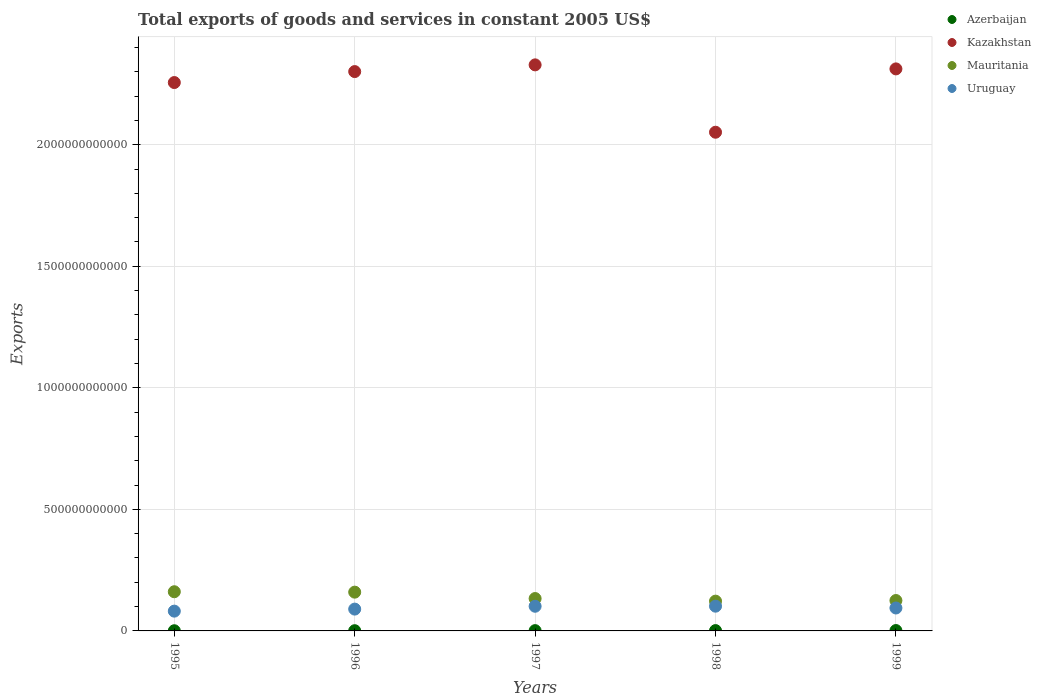What is the total exports of goods and services in Mauritania in 1995?
Ensure brevity in your answer.  1.61e+11. Across all years, what is the maximum total exports of goods and services in Uruguay?
Your answer should be compact. 1.02e+11. Across all years, what is the minimum total exports of goods and services in Azerbaijan?
Your response must be concise. 7.61e+08. In which year was the total exports of goods and services in Azerbaijan maximum?
Give a very brief answer. 1999. What is the total total exports of goods and services in Uruguay in the graph?
Ensure brevity in your answer.  4.69e+11. What is the difference between the total exports of goods and services in Mauritania in 1997 and that in 1998?
Offer a very short reply. 1.08e+1. What is the difference between the total exports of goods and services in Uruguay in 1998 and the total exports of goods and services in Azerbaijan in 1996?
Give a very brief answer. 1.01e+11. What is the average total exports of goods and services in Uruguay per year?
Your answer should be compact. 9.37e+1. In the year 1997, what is the difference between the total exports of goods and services in Azerbaijan and total exports of goods and services in Uruguay?
Provide a short and direct response. -1.00e+11. What is the ratio of the total exports of goods and services in Azerbaijan in 1996 to that in 1998?
Offer a very short reply. 0.67. Is the total exports of goods and services in Azerbaijan in 1996 less than that in 1997?
Offer a terse response. Yes. Is the difference between the total exports of goods and services in Azerbaijan in 1995 and 1998 greater than the difference between the total exports of goods and services in Uruguay in 1995 and 1998?
Provide a succinct answer. Yes. What is the difference between the highest and the second highest total exports of goods and services in Azerbaijan?
Keep it short and to the point. 1.83e+08. What is the difference between the highest and the lowest total exports of goods and services in Azerbaijan?
Keep it short and to the point. 7.80e+08. In how many years, is the total exports of goods and services in Kazakhstan greater than the average total exports of goods and services in Kazakhstan taken over all years?
Offer a very short reply. 4. Is the sum of the total exports of goods and services in Uruguay in 1996 and 1997 greater than the maximum total exports of goods and services in Mauritania across all years?
Your response must be concise. Yes. Is it the case that in every year, the sum of the total exports of goods and services in Mauritania and total exports of goods and services in Kazakhstan  is greater than the sum of total exports of goods and services in Uruguay and total exports of goods and services in Azerbaijan?
Offer a very short reply. Yes. Does the total exports of goods and services in Azerbaijan monotonically increase over the years?
Your response must be concise. Yes. Is the total exports of goods and services in Kazakhstan strictly less than the total exports of goods and services in Mauritania over the years?
Keep it short and to the point. No. How many dotlines are there?
Keep it short and to the point. 4. What is the difference between two consecutive major ticks on the Y-axis?
Provide a succinct answer. 5.00e+11. Are the values on the major ticks of Y-axis written in scientific E-notation?
Provide a short and direct response. No. Does the graph contain any zero values?
Your answer should be compact. No. Where does the legend appear in the graph?
Offer a terse response. Top right. How many legend labels are there?
Your answer should be compact. 4. How are the legend labels stacked?
Ensure brevity in your answer.  Vertical. What is the title of the graph?
Give a very brief answer. Total exports of goods and services in constant 2005 US$. What is the label or title of the X-axis?
Offer a very short reply. Years. What is the label or title of the Y-axis?
Give a very brief answer. Exports. What is the Exports in Azerbaijan in 1995?
Your response must be concise. 7.61e+08. What is the Exports of Kazakhstan in 1995?
Provide a succinct answer. 2.26e+12. What is the Exports in Mauritania in 1995?
Your answer should be compact. 1.61e+11. What is the Exports of Uruguay in 1995?
Offer a terse response. 8.14e+1. What is the Exports of Azerbaijan in 1996?
Offer a terse response. 9.16e+08. What is the Exports in Kazakhstan in 1996?
Your answer should be compact. 2.30e+12. What is the Exports of Mauritania in 1996?
Give a very brief answer. 1.60e+11. What is the Exports in Uruguay in 1996?
Give a very brief answer. 8.98e+1. What is the Exports in Azerbaijan in 1997?
Provide a short and direct response. 1.18e+09. What is the Exports in Kazakhstan in 1997?
Your response must be concise. 2.33e+12. What is the Exports of Mauritania in 1997?
Offer a terse response. 1.33e+11. What is the Exports in Uruguay in 1997?
Provide a succinct answer. 1.01e+11. What is the Exports in Azerbaijan in 1998?
Make the answer very short. 1.36e+09. What is the Exports in Kazakhstan in 1998?
Offer a terse response. 2.05e+12. What is the Exports of Mauritania in 1998?
Give a very brief answer. 1.22e+11. What is the Exports of Uruguay in 1998?
Offer a terse response. 1.02e+11. What is the Exports in Azerbaijan in 1999?
Keep it short and to the point. 1.54e+09. What is the Exports of Kazakhstan in 1999?
Keep it short and to the point. 2.31e+12. What is the Exports of Mauritania in 1999?
Make the answer very short. 1.25e+11. What is the Exports in Uruguay in 1999?
Keep it short and to the point. 9.43e+1. Across all years, what is the maximum Exports of Azerbaijan?
Provide a succinct answer. 1.54e+09. Across all years, what is the maximum Exports of Kazakhstan?
Your response must be concise. 2.33e+12. Across all years, what is the maximum Exports of Mauritania?
Your answer should be very brief. 1.61e+11. Across all years, what is the maximum Exports in Uruguay?
Your answer should be very brief. 1.02e+11. Across all years, what is the minimum Exports of Azerbaijan?
Keep it short and to the point. 7.61e+08. Across all years, what is the minimum Exports in Kazakhstan?
Your response must be concise. 2.05e+12. Across all years, what is the minimum Exports of Mauritania?
Your answer should be compact. 1.22e+11. Across all years, what is the minimum Exports in Uruguay?
Keep it short and to the point. 8.14e+1. What is the total Exports in Azerbaijan in the graph?
Offer a terse response. 5.76e+09. What is the total Exports in Kazakhstan in the graph?
Make the answer very short. 1.12e+13. What is the total Exports in Mauritania in the graph?
Offer a very short reply. 7.01e+11. What is the total Exports in Uruguay in the graph?
Your answer should be very brief. 4.69e+11. What is the difference between the Exports of Azerbaijan in 1995 and that in 1996?
Offer a terse response. -1.55e+08. What is the difference between the Exports in Kazakhstan in 1995 and that in 1996?
Give a very brief answer. -4.51e+1. What is the difference between the Exports in Mauritania in 1995 and that in 1996?
Give a very brief answer. 1.68e+09. What is the difference between the Exports of Uruguay in 1995 and that in 1996?
Give a very brief answer. -8.37e+09. What is the difference between the Exports in Azerbaijan in 1995 and that in 1997?
Provide a succinct answer. -4.22e+08. What is the difference between the Exports in Kazakhstan in 1995 and that in 1997?
Offer a terse response. -7.27e+1. What is the difference between the Exports of Mauritania in 1995 and that in 1997?
Your answer should be very brief. 2.80e+1. What is the difference between the Exports of Uruguay in 1995 and that in 1997?
Offer a very short reply. -2.01e+1. What is the difference between the Exports in Azerbaijan in 1995 and that in 1998?
Make the answer very short. -5.97e+08. What is the difference between the Exports of Kazakhstan in 1995 and that in 1998?
Offer a terse response. 2.04e+11. What is the difference between the Exports of Mauritania in 1995 and that in 1998?
Make the answer very short. 3.87e+1. What is the difference between the Exports in Uruguay in 1995 and that in 1998?
Ensure brevity in your answer.  -2.04e+1. What is the difference between the Exports of Azerbaijan in 1995 and that in 1999?
Give a very brief answer. -7.80e+08. What is the difference between the Exports in Kazakhstan in 1995 and that in 1999?
Provide a short and direct response. -5.62e+1. What is the difference between the Exports in Mauritania in 1995 and that in 1999?
Provide a short and direct response. 3.61e+1. What is the difference between the Exports in Uruguay in 1995 and that in 1999?
Offer a terse response. -1.29e+1. What is the difference between the Exports in Azerbaijan in 1996 and that in 1997?
Give a very brief answer. -2.67e+08. What is the difference between the Exports of Kazakhstan in 1996 and that in 1997?
Provide a short and direct response. -2.76e+1. What is the difference between the Exports of Mauritania in 1996 and that in 1997?
Offer a very short reply. 2.63e+1. What is the difference between the Exports in Uruguay in 1996 and that in 1997?
Keep it short and to the point. -1.17e+1. What is the difference between the Exports in Azerbaijan in 1996 and that in 1998?
Offer a very short reply. -4.43e+08. What is the difference between the Exports in Kazakhstan in 1996 and that in 1998?
Give a very brief answer. 2.49e+11. What is the difference between the Exports in Mauritania in 1996 and that in 1998?
Provide a succinct answer. 3.70e+1. What is the difference between the Exports of Uruguay in 1996 and that in 1998?
Offer a terse response. -1.20e+1. What is the difference between the Exports in Azerbaijan in 1996 and that in 1999?
Offer a very short reply. -6.25e+08. What is the difference between the Exports in Kazakhstan in 1996 and that in 1999?
Your answer should be compact. -1.10e+1. What is the difference between the Exports of Mauritania in 1996 and that in 1999?
Provide a succinct answer. 3.45e+1. What is the difference between the Exports of Uruguay in 1996 and that in 1999?
Offer a very short reply. -4.53e+09. What is the difference between the Exports of Azerbaijan in 1997 and that in 1998?
Provide a succinct answer. -1.75e+08. What is the difference between the Exports in Kazakhstan in 1997 and that in 1998?
Your answer should be compact. 2.77e+11. What is the difference between the Exports of Mauritania in 1997 and that in 1998?
Offer a very short reply. 1.08e+1. What is the difference between the Exports in Uruguay in 1997 and that in 1998?
Your response must be concise. -3.39e+08. What is the difference between the Exports of Azerbaijan in 1997 and that in 1999?
Provide a succinct answer. -3.58e+08. What is the difference between the Exports in Kazakhstan in 1997 and that in 1999?
Offer a very short reply. 1.66e+1. What is the difference between the Exports of Mauritania in 1997 and that in 1999?
Offer a terse response. 8.16e+09. What is the difference between the Exports of Uruguay in 1997 and that in 1999?
Your answer should be very brief. 7.16e+09. What is the difference between the Exports in Azerbaijan in 1998 and that in 1999?
Offer a terse response. -1.83e+08. What is the difference between the Exports of Kazakhstan in 1998 and that in 1999?
Make the answer very short. -2.61e+11. What is the difference between the Exports in Mauritania in 1998 and that in 1999?
Provide a short and direct response. -2.59e+09. What is the difference between the Exports in Uruguay in 1998 and that in 1999?
Provide a short and direct response. 7.50e+09. What is the difference between the Exports of Azerbaijan in 1995 and the Exports of Kazakhstan in 1996?
Ensure brevity in your answer.  -2.30e+12. What is the difference between the Exports in Azerbaijan in 1995 and the Exports in Mauritania in 1996?
Provide a short and direct response. -1.59e+11. What is the difference between the Exports in Azerbaijan in 1995 and the Exports in Uruguay in 1996?
Your response must be concise. -8.90e+1. What is the difference between the Exports of Kazakhstan in 1995 and the Exports of Mauritania in 1996?
Give a very brief answer. 2.10e+12. What is the difference between the Exports of Kazakhstan in 1995 and the Exports of Uruguay in 1996?
Keep it short and to the point. 2.17e+12. What is the difference between the Exports of Mauritania in 1995 and the Exports of Uruguay in 1996?
Your answer should be very brief. 7.14e+1. What is the difference between the Exports in Azerbaijan in 1995 and the Exports in Kazakhstan in 1997?
Give a very brief answer. -2.33e+12. What is the difference between the Exports in Azerbaijan in 1995 and the Exports in Mauritania in 1997?
Offer a terse response. -1.32e+11. What is the difference between the Exports of Azerbaijan in 1995 and the Exports of Uruguay in 1997?
Provide a short and direct response. -1.01e+11. What is the difference between the Exports in Kazakhstan in 1995 and the Exports in Mauritania in 1997?
Your answer should be very brief. 2.12e+12. What is the difference between the Exports in Kazakhstan in 1995 and the Exports in Uruguay in 1997?
Make the answer very short. 2.15e+12. What is the difference between the Exports in Mauritania in 1995 and the Exports in Uruguay in 1997?
Ensure brevity in your answer.  5.97e+1. What is the difference between the Exports in Azerbaijan in 1995 and the Exports in Kazakhstan in 1998?
Provide a succinct answer. -2.05e+12. What is the difference between the Exports of Azerbaijan in 1995 and the Exports of Mauritania in 1998?
Your response must be concise. -1.22e+11. What is the difference between the Exports in Azerbaijan in 1995 and the Exports in Uruguay in 1998?
Keep it short and to the point. -1.01e+11. What is the difference between the Exports in Kazakhstan in 1995 and the Exports in Mauritania in 1998?
Your answer should be very brief. 2.13e+12. What is the difference between the Exports in Kazakhstan in 1995 and the Exports in Uruguay in 1998?
Your response must be concise. 2.15e+12. What is the difference between the Exports in Mauritania in 1995 and the Exports in Uruguay in 1998?
Your response must be concise. 5.94e+1. What is the difference between the Exports in Azerbaijan in 1995 and the Exports in Kazakhstan in 1999?
Offer a very short reply. -2.31e+12. What is the difference between the Exports of Azerbaijan in 1995 and the Exports of Mauritania in 1999?
Provide a short and direct response. -1.24e+11. What is the difference between the Exports in Azerbaijan in 1995 and the Exports in Uruguay in 1999?
Offer a terse response. -9.35e+1. What is the difference between the Exports in Kazakhstan in 1995 and the Exports in Mauritania in 1999?
Provide a short and direct response. 2.13e+12. What is the difference between the Exports in Kazakhstan in 1995 and the Exports in Uruguay in 1999?
Provide a short and direct response. 2.16e+12. What is the difference between the Exports of Mauritania in 1995 and the Exports of Uruguay in 1999?
Your answer should be very brief. 6.69e+1. What is the difference between the Exports of Azerbaijan in 1996 and the Exports of Kazakhstan in 1997?
Your answer should be very brief. -2.33e+12. What is the difference between the Exports in Azerbaijan in 1996 and the Exports in Mauritania in 1997?
Keep it short and to the point. -1.32e+11. What is the difference between the Exports of Azerbaijan in 1996 and the Exports of Uruguay in 1997?
Offer a terse response. -1.01e+11. What is the difference between the Exports of Kazakhstan in 1996 and the Exports of Mauritania in 1997?
Ensure brevity in your answer.  2.17e+12. What is the difference between the Exports in Kazakhstan in 1996 and the Exports in Uruguay in 1997?
Give a very brief answer. 2.20e+12. What is the difference between the Exports in Mauritania in 1996 and the Exports in Uruguay in 1997?
Keep it short and to the point. 5.81e+1. What is the difference between the Exports in Azerbaijan in 1996 and the Exports in Kazakhstan in 1998?
Ensure brevity in your answer.  -2.05e+12. What is the difference between the Exports in Azerbaijan in 1996 and the Exports in Mauritania in 1998?
Your response must be concise. -1.22e+11. What is the difference between the Exports in Azerbaijan in 1996 and the Exports in Uruguay in 1998?
Provide a succinct answer. -1.01e+11. What is the difference between the Exports in Kazakhstan in 1996 and the Exports in Mauritania in 1998?
Your answer should be very brief. 2.18e+12. What is the difference between the Exports of Kazakhstan in 1996 and the Exports of Uruguay in 1998?
Ensure brevity in your answer.  2.20e+12. What is the difference between the Exports in Mauritania in 1996 and the Exports in Uruguay in 1998?
Your response must be concise. 5.77e+1. What is the difference between the Exports in Azerbaijan in 1996 and the Exports in Kazakhstan in 1999?
Your answer should be very brief. -2.31e+12. What is the difference between the Exports of Azerbaijan in 1996 and the Exports of Mauritania in 1999?
Your answer should be very brief. -1.24e+11. What is the difference between the Exports in Azerbaijan in 1996 and the Exports in Uruguay in 1999?
Provide a succinct answer. -9.34e+1. What is the difference between the Exports in Kazakhstan in 1996 and the Exports in Mauritania in 1999?
Make the answer very short. 2.18e+12. What is the difference between the Exports of Kazakhstan in 1996 and the Exports of Uruguay in 1999?
Ensure brevity in your answer.  2.21e+12. What is the difference between the Exports in Mauritania in 1996 and the Exports in Uruguay in 1999?
Keep it short and to the point. 6.52e+1. What is the difference between the Exports of Azerbaijan in 1997 and the Exports of Kazakhstan in 1998?
Offer a very short reply. -2.05e+12. What is the difference between the Exports in Azerbaijan in 1997 and the Exports in Mauritania in 1998?
Your response must be concise. -1.21e+11. What is the difference between the Exports of Azerbaijan in 1997 and the Exports of Uruguay in 1998?
Give a very brief answer. -1.01e+11. What is the difference between the Exports in Kazakhstan in 1997 and the Exports in Mauritania in 1998?
Offer a very short reply. 2.21e+12. What is the difference between the Exports in Kazakhstan in 1997 and the Exports in Uruguay in 1998?
Provide a short and direct response. 2.23e+12. What is the difference between the Exports of Mauritania in 1997 and the Exports of Uruguay in 1998?
Your answer should be very brief. 3.14e+1. What is the difference between the Exports of Azerbaijan in 1997 and the Exports of Kazakhstan in 1999?
Provide a succinct answer. -2.31e+12. What is the difference between the Exports in Azerbaijan in 1997 and the Exports in Mauritania in 1999?
Offer a terse response. -1.24e+11. What is the difference between the Exports in Azerbaijan in 1997 and the Exports in Uruguay in 1999?
Provide a succinct answer. -9.31e+1. What is the difference between the Exports of Kazakhstan in 1997 and the Exports of Mauritania in 1999?
Keep it short and to the point. 2.20e+12. What is the difference between the Exports in Kazakhstan in 1997 and the Exports in Uruguay in 1999?
Offer a terse response. 2.23e+12. What is the difference between the Exports of Mauritania in 1997 and the Exports of Uruguay in 1999?
Offer a very short reply. 3.89e+1. What is the difference between the Exports of Azerbaijan in 1998 and the Exports of Kazakhstan in 1999?
Give a very brief answer. -2.31e+12. What is the difference between the Exports in Azerbaijan in 1998 and the Exports in Mauritania in 1999?
Give a very brief answer. -1.24e+11. What is the difference between the Exports of Azerbaijan in 1998 and the Exports of Uruguay in 1999?
Your response must be concise. -9.29e+1. What is the difference between the Exports of Kazakhstan in 1998 and the Exports of Mauritania in 1999?
Provide a short and direct response. 1.93e+12. What is the difference between the Exports of Kazakhstan in 1998 and the Exports of Uruguay in 1999?
Your response must be concise. 1.96e+12. What is the difference between the Exports in Mauritania in 1998 and the Exports in Uruguay in 1999?
Your answer should be very brief. 2.82e+1. What is the average Exports in Azerbaijan per year?
Your response must be concise. 1.15e+09. What is the average Exports in Kazakhstan per year?
Your answer should be compact. 2.25e+12. What is the average Exports of Mauritania per year?
Keep it short and to the point. 1.40e+11. What is the average Exports of Uruguay per year?
Your answer should be compact. 9.37e+1. In the year 1995, what is the difference between the Exports of Azerbaijan and Exports of Kazakhstan?
Your answer should be very brief. -2.26e+12. In the year 1995, what is the difference between the Exports in Azerbaijan and Exports in Mauritania?
Your answer should be compact. -1.60e+11. In the year 1995, what is the difference between the Exports of Azerbaijan and Exports of Uruguay?
Your answer should be very brief. -8.06e+1. In the year 1995, what is the difference between the Exports in Kazakhstan and Exports in Mauritania?
Ensure brevity in your answer.  2.09e+12. In the year 1995, what is the difference between the Exports in Kazakhstan and Exports in Uruguay?
Give a very brief answer. 2.17e+12. In the year 1995, what is the difference between the Exports in Mauritania and Exports in Uruguay?
Offer a terse response. 7.98e+1. In the year 1996, what is the difference between the Exports of Azerbaijan and Exports of Kazakhstan?
Your answer should be compact. -2.30e+12. In the year 1996, what is the difference between the Exports in Azerbaijan and Exports in Mauritania?
Ensure brevity in your answer.  -1.59e+11. In the year 1996, what is the difference between the Exports of Azerbaijan and Exports of Uruguay?
Give a very brief answer. -8.89e+1. In the year 1996, what is the difference between the Exports of Kazakhstan and Exports of Mauritania?
Make the answer very short. 2.14e+12. In the year 1996, what is the difference between the Exports of Kazakhstan and Exports of Uruguay?
Your answer should be very brief. 2.21e+12. In the year 1996, what is the difference between the Exports in Mauritania and Exports in Uruguay?
Provide a short and direct response. 6.97e+1. In the year 1997, what is the difference between the Exports of Azerbaijan and Exports of Kazakhstan?
Provide a short and direct response. -2.33e+12. In the year 1997, what is the difference between the Exports of Azerbaijan and Exports of Mauritania?
Offer a terse response. -1.32e+11. In the year 1997, what is the difference between the Exports in Azerbaijan and Exports in Uruguay?
Offer a very short reply. -1.00e+11. In the year 1997, what is the difference between the Exports of Kazakhstan and Exports of Mauritania?
Your answer should be very brief. 2.20e+12. In the year 1997, what is the difference between the Exports in Kazakhstan and Exports in Uruguay?
Your answer should be compact. 2.23e+12. In the year 1997, what is the difference between the Exports in Mauritania and Exports in Uruguay?
Your answer should be compact. 3.18e+1. In the year 1998, what is the difference between the Exports in Azerbaijan and Exports in Kazakhstan?
Your answer should be compact. -2.05e+12. In the year 1998, what is the difference between the Exports in Azerbaijan and Exports in Mauritania?
Offer a very short reply. -1.21e+11. In the year 1998, what is the difference between the Exports of Azerbaijan and Exports of Uruguay?
Make the answer very short. -1.00e+11. In the year 1998, what is the difference between the Exports of Kazakhstan and Exports of Mauritania?
Make the answer very short. 1.93e+12. In the year 1998, what is the difference between the Exports in Kazakhstan and Exports in Uruguay?
Your response must be concise. 1.95e+12. In the year 1998, what is the difference between the Exports in Mauritania and Exports in Uruguay?
Keep it short and to the point. 2.07e+1. In the year 1999, what is the difference between the Exports in Azerbaijan and Exports in Kazakhstan?
Keep it short and to the point. -2.31e+12. In the year 1999, what is the difference between the Exports of Azerbaijan and Exports of Mauritania?
Your response must be concise. -1.24e+11. In the year 1999, what is the difference between the Exports in Azerbaijan and Exports in Uruguay?
Offer a terse response. -9.28e+1. In the year 1999, what is the difference between the Exports in Kazakhstan and Exports in Mauritania?
Give a very brief answer. 2.19e+12. In the year 1999, what is the difference between the Exports of Kazakhstan and Exports of Uruguay?
Offer a very short reply. 2.22e+12. In the year 1999, what is the difference between the Exports of Mauritania and Exports of Uruguay?
Provide a succinct answer. 3.08e+1. What is the ratio of the Exports of Azerbaijan in 1995 to that in 1996?
Provide a short and direct response. 0.83. What is the ratio of the Exports in Kazakhstan in 1995 to that in 1996?
Provide a short and direct response. 0.98. What is the ratio of the Exports in Mauritania in 1995 to that in 1996?
Offer a very short reply. 1.01. What is the ratio of the Exports in Uruguay in 1995 to that in 1996?
Your answer should be compact. 0.91. What is the ratio of the Exports in Azerbaijan in 1995 to that in 1997?
Offer a very short reply. 0.64. What is the ratio of the Exports in Kazakhstan in 1995 to that in 1997?
Your answer should be compact. 0.97. What is the ratio of the Exports of Mauritania in 1995 to that in 1997?
Offer a terse response. 1.21. What is the ratio of the Exports in Uruguay in 1995 to that in 1997?
Provide a short and direct response. 0.8. What is the ratio of the Exports in Azerbaijan in 1995 to that in 1998?
Keep it short and to the point. 0.56. What is the ratio of the Exports of Kazakhstan in 1995 to that in 1998?
Make the answer very short. 1.1. What is the ratio of the Exports of Mauritania in 1995 to that in 1998?
Your answer should be compact. 1.32. What is the ratio of the Exports of Uruguay in 1995 to that in 1998?
Your response must be concise. 0.8. What is the ratio of the Exports in Azerbaijan in 1995 to that in 1999?
Offer a very short reply. 0.49. What is the ratio of the Exports of Kazakhstan in 1995 to that in 1999?
Offer a very short reply. 0.98. What is the ratio of the Exports of Mauritania in 1995 to that in 1999?
Keep it short and to the point. 1.29. What is the ratio of the Exports of Uruguay in 1995 to that in 1999?
Keep it short and to the point. 0.86. What is the ratio of the Exports in Azerbaijan in 1996 to that in 1997?
Ensure brevity in your answer.  0.77. What is the ratio of the Exports of Mauritania in 1996 to that in 1997?
Your response must be concise. 1.2. What is the ratio of the Exports in Uruguay in 1996 to that in 1997?
Make the answer very short. 0.88. What is the ratio of the Exports in Azerbaijan in 1996 to that in 1998?
Provide a succinct answer. 0.67. What is the ratio of the Exports of Kazakhstan in 1996 to that in 1998?
Give a very brief answer. 1.12. What is the ratio of the Exports of Mauritania in 1996 to that in 1998?
Provide a short and direct response. 1.3. What is the ratio of the Exports of Uruguay in 1996 to that in 1998?
Your answer should be very brief. 0.88. What is the ratio of the Exports in Azerbaijan in 1996 to that in 1999?
Offer a very short reply. 0.59. What is the ratio of the Exports of Mauritania in 1996 to that in 1999?
Your answer should be very brief. 1.28. What is the ratio of the Exports of Uruguay in 1996 to that in 1999?
Your response must be concise. 0.95. What is the ratio of the Exports of Azerbaijan in 1997 to that in 1998?
Ensure brevity in your answer.  0.87. What is the ratio of the Exports of Kazakhstan in 1997 to that in 1998?
Provide a succinct answer. 1.14. What is the ratio of the Exports of Mauritania in 1997 to that in 1998?
Ensure brevity in your answer.  1.09. What is the ratio of the Exports of Uruguay in 1997 to that in 1998?
Your response must be concise. 1. What is the ratio of the Exports in Azerbaijan in 1997 to that in 1999?
Keep it short and to the point. 0.77. What is the ratio of the Exports of Kazakhstan in 1997 to that in 1999?
Provide a succinct answer. 1.01. What is the ratio of the Exports of Mauritania in 1997 to that in 1999?
Give a very brief answer. 1.07. What is the ratio of the Exports in Uruguay in 1997 to that in 1999?
Ensure brevity in your answer.  1.08. What is the ratio of the Exports of Azerbaijan in 1998 to that in 1999?
Offer a terse response. 0.88. What is the ratio of the Exports of Kazakhstan in 1998 to that in 1999?
Your answer should be very brief. 0.89. What is the ratio of the Exports in Mauritania in 1998 to that in 1999?
Your answer should be very brief. 0.98. What is the ratio of the Exports in Uruguay in 1998 to that in 1999?
Offer a very short reply. 1.08. What is the difference between the highest and the second highest Exports in Azerbaijan?
Keep it short and to the point. 1.83e+08. What is the difference between the highest and the second highest Exports in Kazakhstan?
Provide a short and direct response. 1.66e+1. What is the difference between the highest and the second highest Exports in Mauritania?
Give a very brief answer. 1.68e+09. What is the difference between the highest and the second highest Exports of Uruguay?
Provide a succinct answer. 3.39e+08. What is the difference between the highest and the lowest Exports of Azerbaijan?
Offer a terse response. 7.80e+08. What is the difference between the highest and the lowest Exports in Kazakhstan?
Your answer should be compact. 2.77e+11. What is the difference between the highest and the lowest Exports in Mauritania?
Provide a short and direct response. 3.87e+1. What is the difference between the highest and the lowest Exports of Uruguay?
Your answer should be very brief. 2.04e+1. 